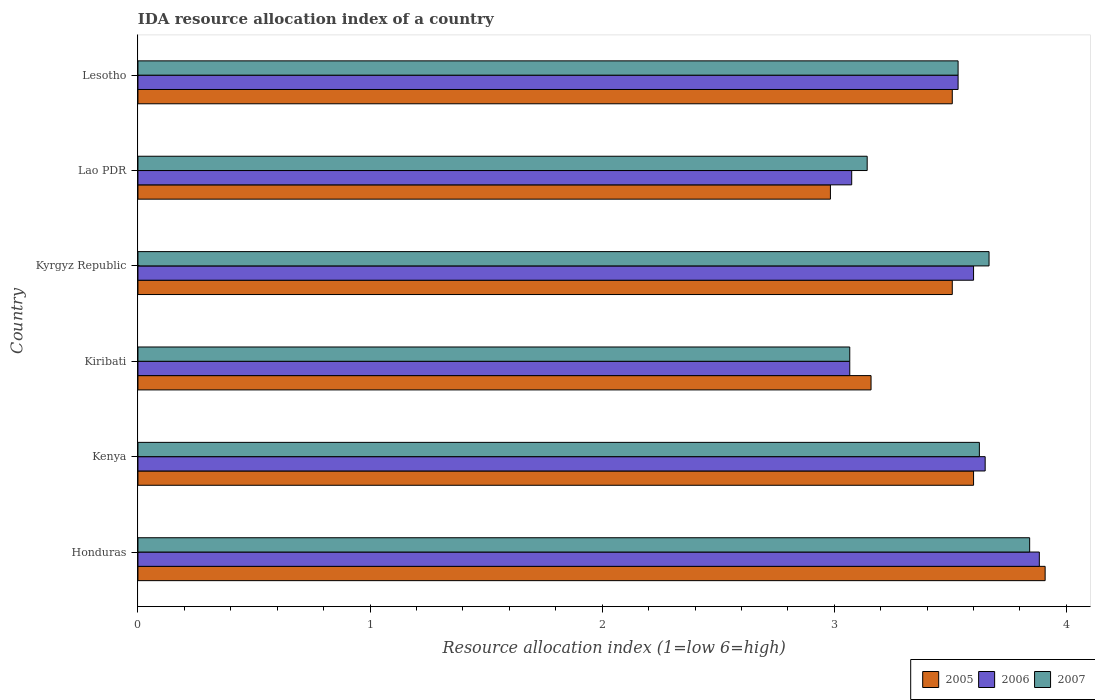How many different coloured bars are there?
Provide a short and direct response. 3. How many groups of bars are there?
Your answer should be compact. 6. What is the label of the 6th group of bars from the top?
Provide a succinct answer. Honduras. In how many cases, is the number of bars for a given country not equal to the number of legend labels?
Provide a short and direct response. 0. What is the IDA resource allocation index in 2007 in Lesotho?
Offer a terse response. 3.53. Across all countries, what is the maximum IDA resource allocation index in 2007?
Your answer should be compact. 3.84. Across all countries, what is the minimum IDA resource allocation index in 2006?
Give a very brief answer. 3.07. In which country was the IDA resource allocation index in 2005 maximum?
Offer a very short reply. Honduras. In which country was the IDA resource allocation index in 2005 minimum?
Make the answer very short. Lao PDR. What is the total IDA resource allocation index in 2007 in the graph?
Offer a very short reply. 20.88. What is the difference between the IDA resource allocation index in 2007 in Honduras and that in Kenya?
Your answer should be compact. 0.22. What is the difference between the IDA resource allocation index in 2005 in Honduras and the IDA resource allocation index in 2006 in Kenya?
Your answer should be compact. 0.26. What is the average IDA resource allocation index in 2006 per country?
Your answer should be very brief. 3.47. What is the difference between the IDA resource allocation index in 2005 and IDA resource allocation index in 2007 in Honduras?
Provide a succinct answer. 0.07. In how many countries, is the IDA resource allocation index in 2005 greater than 0.2 ?
Ensure brevity in your answer.  6. What is the ratio of the IDA resource allocation index in 2007 in Kiribati to that in Lesotho?
Make the answer very short. 0.87. What is the difference between the highest and the second highest IDA resource allocation index in 2006?
Make the answer very short. 0.23. What is the difference between the highest and the lowest IDA resource allocation index in 2005?
Your answer should be very brief. 0.93. In how many countries, is the IDA resource allocation index in 2006 greater than the average IDA resource allocation index in 2006 taken over all countries?
Provide a succinct answer. 4. Is the sum of the IDA resource allocation index in 2006 in Honduras and Lesotho greater than the maximum IDA resource allocation index in 2005 across all countries?
Provide a short and direct response. Yes. Is it the case that in every country, the sum of the IDA resource allocation index in 2005 and IDA resource allocation index in 2007 is greater than the IDA resource allocation index in 2006?
Offer a terse response. Yes. How many bars are there?
Offer a terse response. 18. Are all the bars in the graph horizontal?
Your answer should be compact. Yes. How many countries are there in the graph?
Give a very brief answer. 6. Are the values on the major ticks of X-axis written in scientific E-notation?
Provide a short and direct response. No. Does the graph contain any zero values?
Provide a succinct answer. No. Does the graph contain grids?
Keep it short and to the point. No. How many legend labels are there?
Ensure brevity in your answer.  3. What is the title of the graph?
Offer a very short reply. IDA resource allocation index of a country. What is the label or title of the X-axis?
Your answer should be very brief. Resource allocation index (1=low 6=high). What is the Resource allocation index (1=low 6=high) of 2005 in Honduras?
Offer a terse response. 3.91. What is the Resource allocation index (1=low 6=high) in 2006 in Honduras?
Provide a short and direct response. 3.88. What is the Resource allocation index (1=low 6=high) in 2007 in Honduras?
Give a very brief answer. 3.84. What is the Resource allocation index (1=low 6=high) in 2006 in Kenya?
Keep it short and to the point. 3.65. What is the Resource allocation index (1=low 6=high) in 2007 in Kenya?
Provide a succinct answer. 3.62. What is the Resource allocation index (1=low 6=high) in 2005 in Kiribati?
Ensure brevity in your answer.  3.16. What is the Resource allocation index (1=low 6=high) of 2006 in Kiribati?
Ensure brevity in your answer.  3.07. What is the Resource allocation index (1=low 6=high) of 2007 in Kiribati?
Give a very brief answer. 3.07. What is the Resource allocation index (1=low 6=high) in 2005 in Kyrgyz Republic?
Your answer should be very brief. 3.51. What is the Resource allocation index (1=low 6=high) in 2007 in Kyrgyz Republic?
Make the answer very short. 3.67. What is the Resource allocation index (1=low 6=high) in 2005 in Lao PDR?
Ensure brevity in your answer.  2.98. What is the Resource allocation index (1=low 6=high) of 2006 in Lao PDR?
Your answer should be very brief. 3.08. What is the Resource allocation index (1=low 6=high) of 2007 in Lao PDR?
Provide a succinct answer. 3.14. What is the Resource allocation index (1=low 6=high) of 2005 in Lesotho?
Your answer should be very brief. 3.51. What is the Resource allocation index (1=low 6=high) of 2006 in Lesotho?
Provide a succinct answer. 3.53. What is the Resource allocation index (1=low 6=high) of 2007 in Lesotho?
Your answer should be compact. 3.53. Across all countries, what is the maximum Resource allocation index (1=low 6=high) of 2005?
Provide a short and direct response. 3.91. Across all countries, what is the maximum Resource allocation index (1=low 6=high) of 2006?
Your response must be concise. 3.88. Across all countries, what is the maximum Resource allocation index (1=low 6=high) of 2007?
Give a very brief answer. 3.84. Across all countries, what is the minimum Resource allocation index (1=low 6=high) of 2005?
Offer a very short reply. 2.98. Across all countries, what is the minimum Resource allocation index (1=low 6=high) of 2006?
Provide a short and direct response. 3.07. Across all countries, what is the minimum Resource allocation index (1=low 6=high) of 2007?
Make the answer very short. 3.07. What is the total Resource allocation index (1=low 6=high) of 2005 in the graph?
Give a very brief answer. 20.67. What is the total Resource allocation index (1=low 6=high) in 2006 in the graph?
Your response must be concise. 20.81. What is the total Resource allocation index (1=low 6=high) in 2007 in the graph?
Your response must be concise. 20.88. What is the difference between the Resource allocation index (1=low 6=high) of 2005 in Honduras and that in Kenya?
Provide a succinct answer. 0.31. What is the difference between the Resource allocation index (1=low 6=high) of 2006 in Honduras and that in Kenya?
Your answer should be very brief. 0.23. What is the difference between the Resource allocation index (1=low 6=high) in 2007 in Honduras and that in Kenya?
Your response must be concise. 0.22. What is the difference between the Resource allocation index (1=low 6=high) of 2005 in Honduras and that in Kiribati?
Ensure brevity in your answer.  0.75. What is the difference between the Resource allocation index (1=low 6=high) of 2006 in Honduras and that in Kiribati?
Ensure brevity in your answer.  0.82. What is the difference between the Resource allocation index (1=low 6=high) in 2007 in Honduras and that in Kiribati?
Give a very brief answer. 0.78. What is the difference between the Resource allocation index (1=low 6=high) of 2006 in Honduras and that in Kyrgyz Republic?
Your response must be concise. 0.28. What is the difference between the Resource allocation index (1=low 6=high) of 2007 in Honduras and that in Kyrgyz Republic?
Offer a very short reply. 0.17. What is the difference between the Resource allocation index (1=low 6=high) of 2005 in Honduras and that in Lao PDR?
Offer a terse response. 0.93. What is the difference between the Resource allocation index (1=low 6=high) of 2006 in Honduras and that in Lao PDR?
Ensure brevity in your answer.  0.81. What is the difference between the Resource allocation index (1=low 6=high) of 2007 in Honduras and that in Lao PDR?
Your response must be concise. 0.7. What is the difference between the Resource allocation index (1=low 6=high) in 2007 in Honduras and that in Lesotho?
Make the answer very short. 0.31. What is the difference between the Resource allocation index (1=low 6=high) of 2005 in Kenya and that in Kiribati?
Offer a very short reply. 0.44. What is the difference between the Resource allocation index (1=low 6=high) of 2006 in Kenya and that in Kiribati?
Offer a very short reply. 0.58. What is the difference between the Resource allocation index (1=low 6=high) in 2007 in Kenya and that in Kiribati?
Provide a short and direct response. 0.56. What is the difference between the Resource allocation index (1=low 6=high) in 2005 in Kenya and that in Kyrgyz Republic?
Give a very brief answer. 0.09. What is the difference between the Resource allocation index (1=low 6=high) in 2007 in Kenya and that in Kyrgyz Republic?
Your response must be concise. -0.04. What is the difference between the Resource allocation index (1=low 6=high) of 2005 in Kenya and that in Lao PDR?
Make the answer very short. 0.62. What is the difference between the Resource allocation index (1=low 6=high) of 2006 in Kenya and that in Lao PDR?
Offer a very short reply. 0.57. What is the difference between the Resource allocation index (1=low 6=high) of 2007 in Kenya and that in Lao PDR?
Make the answer very short. 0.48. What is the difference between the Resource allocation index (1=low 6=high) in 2005 in Kenya and that in Lesotho?
Your response must be concise. 0.09. What is the difference between the Resource allocation index (1=low 6=high) of 2006 in Kenya and that in Lesotho?
Offer a terse response. 0.12. What is the difference between the Resource allocation index (1=low 6=high) in 2007 in Kenya and that in Lesotho?
Your answer should be compact. 0.09. What is the difference between the Resource allocation index (1=low 6=high) of 2005 in Kiribati and that in Kyrgyz Republic?
Your answer should be very brief. -0.35. What is the difference between the Resource allocation index (1=low 6=high) of 2006 in Kiribati and that in Kyrgyz Republic?
Keep it short and to the point. -0.53. What is the difference between the Resource allocation index (1=low 6=high) of 2005 in Kiribati and that in Lao PDR?
Your response must be concise. 0.17. What is the difference between the Resource allocation index (1=low 6=high) in 2006 in Kiribati and that in Lao PDR?
Provide a short and direct response. -0.01. What is the difference between the Resource allocation index (1=low 6=high) in 2007 in Kiribati and that in Lao PDR?
Give a very brief answer. -0.07. What is the difference between the Resource allocation index (1=low 6=high) of 2005 in Kiribati and that in Lesotho?
Offer a terse response. -0.35. What is the difference between the Resource allocation index (1=low 6=high) in 2006 in Kiribati and that in Lesotho?
Offer a very short reply. -0.47. What is the difference between the Resource allocation index (1=low 6=high) of 2007 in Kiribati and that in Lesotho?
Ensure brevity in your answer.  -0.47. What is the difference between the Resource allocation index (1=low 6=high) in 2005 in Kyrgyz Republic and that in Lao PDR?
Provide a short and direct response. 0.53. What is the difference between the Resource allocation index (1=low 6=high) in 2006 in Kyrgyz Republic and that in Lao PDR?
Offer a terse response. 0.53. What is the difference between the Resource allocation index (1=low 6=high) of 2007 in Kyrgyz Republic and that in Lao PDR?
Keep it short and to the point. 0.53. What is the difference between the Resource allocation index (1=low 6=high) in 2005 in Kyrgyz Republic and that in Lesotho?
Offer a very short reply. 0. What is the difference between the Resource allocation index (1=low 6=high) of 2006 in Kyrgyz Republic and that in Lesotho?
Provide a succinct answer. 0.07. What is the difference between the Resource allocation index (1=low 6=high) of 2007 in Kyrgyz Republic and that in Lesotho?
Offer a terse response. 0.13. What is the difference between the Resource allocation index (1=low 6=high) in 2005 in Lao PDR and that in Lesotho?
Give a very brief answer. -0.53. What is the difference between the Resource allocation index (1=low 6=high) of 2006 in Lao PDR and that in Lesotho?
Keep it short and to the point. -0.46. What is the difference between the Resource allocation index (1=low 6=high) of 2007 in Lao PDR and that in Lesotho?
Ensure brevity in your answer.  -0.39. What is the difference between the Resource allocation index (1=low 6=high) in 2005 in Honduras and the Resource allocation index (1=low 6=high) in 2006 in Kenya?
Offer a terse response. 0.26. What is the difference between the Resource allocation index (1=low 6=high) of 2005 in Honduras and the Resource allocation index (1=low 6=high) of 2007 in Kenya?
Give a very brief answer. 0.28. What is the difference between the Resource allocation index (1=low 6=high) of 2006 in Honduras and the Resource allocation index (1=low 6=high) of 2007 in Kenya?
Keep it short and to the point. 0.26. What is the difference between the Resource allocation index (1=low 6=high) in 2005 in Honduras and the Resource allocation index (1=low 6=high) in 2006 in Kiribati?
Give a very brief answer. 0.84. What is the difference between the Resource allocation index (1=low 6=high) in 2005 in Honduras and the Resource allocation index (1=low 6=high) in 2007 in Kiribati?
Provide a succinct answer. 0.84. What is the difference between the Resource allocation index (1=low 6=high) in 2006 in Honduras and the Resource allocation index (1=low 6=high) in 2007 in Kiribati?
Your answer should be very brief. 0.82. What is the difference between the Resource allocation index (1=low 6=high) of 2005 in Honduras and the Resource allocation index (1=low 6=high) of 2006 in Kyrgyz Republic?
Offer a terse response. 0.31. What is the difference between the Resource allocation index (1=low 6=high) in 2005 in Honduras and the Resource allocation index (1=low 6=high) in 2007 in Kyrgyz Republic?
Provide a succinct answer. 0.24. What is the difference between the Resource allocation index (1=low 6=high) in 2006 in Honduras and the Resource allocation index (1=low 6=high) in 2007 in Kyrgyz Republic?
Offer a terse response. 0.22. What is the difference between the Resource allocation index (1=low 6=high) of 2005 in Honduras and the Resource allocation index (1=low 6=high) of 2006 in Lao PDR?
Offer a terse response. 0.83. What is the difference between the Resource allocation index (1=low 6=high) of 2005 in Honduras and the Resource allocation index (1=low 6=high) of 2007 in Lao PDR?
Make the answer very short. 0.77. What is the difference between the Resource allocation index (1=low 6=high) in 2006 in Honduras and the Resource allocation index (1=low 6=high) in 2007 in Lao PDR?
Your answer should be compact. 0.74. What is the difference between the Resource allocation index (1=low 6=high) in 2005 in Honduras and the Resource allocation index (1=low 6=high) in 2007 in Lesotho?
Your answer should be compact. 0.38. What is the difference between the Resource allocation index (1=low 6=high) in 2005 in Kenya and the Resource allocation index (1=low 6=high) in 2006 in Kiribati?
Provide a short and direct response. 0.53. What is the difference between the Resource allocation index (1=low 6=high) in 2005 in Kenya and the Resource allocation index (1=low 6=high) in 2007 in Kiribati?
Give a very brief answer. 0.53. What is the difference between the Resource allocation index (1=low 6=high) of 2006 in Kenya and the Resource allocation index (1=low 6=high) of 2007 in Kiribati?
Ensure brevity in your answer.  0.58. What is the difference between the Resource allocation index (1=low 6=high) in 2005 in Kenya and the Resource allocation index (1=low 6=high) in 2006 in Kyrgyz Republic?
Give a very brief answer. 0. What is the difference between the Resource allocation index (1=low 6=high) in 2005 in Kenya and the Resource allocation index (1=low 6=high) in 2007 in Kyrgyz Republic?
Offer a terse response. -0.07. What is the difference between the Resource allocation index (1=low 6=high) of 2006 in Kenya and the Resource allocation index (1=low 6=high) of 2007 in Kyrgyz Republic?
Offer a terse response. -0.02. What is the difference between the Resource allocation index (1=low 6=high) in 2005 in Kenya and the Resource allocation index (1=low 6=high) in 2006 in Lao PDR?
Your response must be concise. 0.53. What is the difference between the Resource allocation index (1=low 6=high) of 2005 in Kenya and the Resource allocation index (1=low 6=high) of 2007 in Lao PDR?
Offer a very short reply. 0.46. What is the difference between the Resource allocation index (1=low 6=high) of 2006 in Kenya and the Resource allocation index (1=low 6=high) of 2007 in Lao PDR?
Your answer should be compact. 0.51. What is the difference between the Resource allocation index (1=low 6=high) in 2005 in Kenya and the Resource allocation index (1=low 6=high) in 2006 in Lesotho?
Your answer should be very brief. 0.07. What is the difference between the Resource allocation index (1=low 6=high) of 2005 in Kenya and the Resource allocation index (1=low 6=high) of 2007 in Lesotho?
Ensure brevity in your answer.  0.07. What is the difference between the Resource allocation index (1=low 6=high) of 2006 in Kenya and the Resource allocation index (1=low 6=high) of 2007 in Lesotho?
Make the answer very short. 0.12. What is the difference between the Resource allocation index (1=low 6=high) in 2005 in Kiribati and the Resource allocation index (1=low 6=high) in 2006 in Kyrgyz Republic?
Provide a short and direct response. -0.44. What is the difference between the Resource allocation index (1=low 6=high) of 2005 in Kiribati and the Resource allocation index (1=low 6=high) of 2007 in Kyrgyz Republic?
Provide a succinct answer. -0.51. What is the difference between the Resource allocation index (1=low 6=high) of 2006 in Kiribati and the Resource allocation index (1=low 6=high) of 2007 in Kyrgyz Republic?
Provide a short and direct response. -0.6. What is the difference between the Resource allocation index (1=low 6=high) in 2005 in Kiribati and the Resource allocation index (1=low 6=high) in 2006 in Lao PDR?
Your response must be concise. 0.08. What is the difference between the Resource allocation index (1=low 6=high) in 2005 in Kiribati and the Resource allocation index (1=low 6=high) in 2007 in Lao PDR?
Your response must be concise. 0.02. What is the difference between the Resource allocation index (1=low 6=high) in 2006 in Kiribati and the Resource allocation index (1=low 6=high) in 2007 in Lao PDR?
Ensure brevity in your answer.  -0.07. What is the difference between the Resource allocation index (1=low 6=high) in 2005 in Kiribati and the Resource allocation index (1=low 6=high) in 2006 in Lesotho?
Give a very brief answer. -0.38. What is the difference between the Resource allocation index (1=low 6=high) in 2005 in Kiribati and the Resource allocation index (1=low 6=high) in 2007 in Lesotho?
Your answer should be compact. -0.38. What is the difference between the Resource allocation index (1=low 6=high) of 2006 in Kiribati and the Resource allocation index (1=low 6=high) of 2007 in Lesotho?
Make the answer very short. -0.47. What is the difference between the Resource allocation index (1=low 6=high) in 2005 in Kyrgyz Republic and the Resource allocation index (1=low 6=high) in 2006 in Lao PDR?
Make the answer very short. 0.43. What is the difference between the Resource allocation index (1=low 6=high) in 2005 in Kyrgyz Republic and the Resource allocation index (1=low 6=high) in 2007 in Lao PDR?
Give a very brief answer. 0.37. What is the difference between the Resource allocation index (1=low 6=high) of 2006 in Kyrgyz Republic and the Resource allocation index (1=low 6=high) of 2007 in Lao PDR?
Offer a very short reply. 0.46. What is the difference between the Resource allocation index (1=low 6=high) in 2005 in Kyrgyz Republic and the Resource allocation index (1=low 6=high) in 2006 in Lesotho?
Make the answer very short. -0.03. What is the difference between the Resource allocation index (1=low 6=high) of 2005 in Kyrgyz Republic and the Resource allocation index (1=low 6=high) of 2007 in Lesotho?
Give a very brief answer. -0.03. What is the difference between the Resource allocation index (1=low 6=high) of 2006 in Kyrgyz Republic and the Resource allocation index (1=low 6=high) of 2007 in Lesotho?
Make the answer very short. 0.07. What is the difference between the Resource allocation index (1=low 6=high) in 2005 in Lao PDR and the Resource allocation index (1=low 6=high) in 2006 in Lesotho?
Give a very brief answer. -0.55. What is the difference between the Resource allocation index (1=low 6=high) of 2005 in Lao PDR and the Resource allocation index (1=low 6=high) of 2007 in Lesotho?
Give a very brief answer. -0.55. What is the difference between the Resource allocation index (1=low 6=high) in 2006 in Lao PDR and the Resource allocation index (1=low 6=high) in 2007 in Lesotho?
Ensure brevity in your answer.  -0.46. What is the average Resource allocation index (1=low 6=high) of 2005 per country?
Offer a terse response. 3.44. What is the average Resource allocation index (1=low 6=high) in 2006 per country?
Your response must be concise. 3.47. What is the average Resource allocation index (1=low 6=high) of 2007 per country?
Provide a succinct answer. 3.48. What is the difference between the Resource allocation index (1=low 6=high) in 2005 and Resource allocation index (1=low 6=high) in 2006 in Honduras?
Offer a terse response. 0.03. What is the difference between the Resource allocation index (1=low 6=high) in 2005 and Resource allocation index (1=low 6=high) in 2007 in Honduras?
Provide a short and direct response. 0.07. What is the difference between the Resource allocation index (1=low 6=high) in 2006 and Resource allocation index (1=low 6=high) in 2007 in Honduras?
Provide a short and direct response. 0.04. What is the difference between the Resource allocation index (1=low 6=high) of 2005 and Resource allocation index (1=low 6=high) of 2006 in Kenya?
Your response must be concise. -0.05. What is the difference between the Resource allocation index (1=low 6=high) of 2005 and Resource allocation index (1=low 6=high) of 2007 in Kenya?
Provide a short and direct response. -0.03. What is the difference between the Resource allocation index (1=low 6=high) of 2006 and Resource allocation index (1=low 6=high) of 2007 in Kenya?
Your answer should be very brief. 0.03. What is the difference between the Resource allocation index (1=low 6=high) in 2005 and Resource allocation index (1=low 6=high) in 2006 in Kiribati?
Your answer should be compact. 0.09. What is the difference between the Resource allocation index (1=low 6=high) of 2005 and Resource allocation index (1=low 6=high) of 2007 in Kiribati?
Keep it short and to the point. 0.09. What is the difference between the Resource allocation index (1=low 6=high) of 2005 and Resource allocation index (1=low 6=high) of 2006 in Kyrgyz Republic?
Provide a succinct answer. -0.09. What is the difference between the Resource allocation index (1=low 6=high) in 2005 and Resource allocation index (1=low 6=high) in 2007 in Kyrgyz Republic?
Ensure brevity in your answer.  -0.16. What is the difference between the Resource allocation index (1=low 6=high) of 2006 and Resource allocation index (1=low 6=high) of 2007 in Kyrgyz Republic?
Keep it short and to the point. -0.07. What is the difference between the Resource allocation index (1=low 6=high) in 2005 and Resource allocation index (1=low 6=high) in 2006 in Lao PDR?
Provide a succinct answer. -0.09. What is the difference between the Resource allocation index (1=low 6=high) of 2005 and Resource allocation index (1=low 6=high) of 2007 in Lao PDR?
Give a very brief answer. -0.16. What is the difference between the Resource allocation index (1=low 6=high) of 2006 and Resource allocation index (1=low 6=high) of 2007 in Lao PDR?
Ensure brevity in your answer.  -0.07. What is the difference between the Resource allocation index (1=low 6=high) in 2005 and Resource allocation index (1=low 6=high) in 2006 in Lesotho?
Keep it short and to the point. -0.03. What is the difference between the Resource allocation index (1=low 6=high) of 2005 and Resource allocation index (1=low 6=high) of 2007 in Lesotho?
Provide a short and direct response. -0.03. What is the ratio of the Resource allocation index (1=low 6=high) of 2005 in Honduras to that in Kenya?
Give a very brief answer. 1.09. What is the ratio of the Resource allocation index (1=low 6=high) in 2006 in Honduras to that in Kenya?
Make the answer very short. 1.06. What is the ratio of the Resource allocation index (1=low 6=high) in 2007 in Honduras to that in Kenya?
Offer a terse response. 1.06. What is the ratio of the Resource allocation index (1=low 6=high) of 2005 in Honduras to that in Kiribati?
Give a very brief answer. 1.24. What is the ratio of the Resource allocation index (1=low 6=high) of 2006 in Honduras to that in Kiribati?
Make the answer very short. 1.27. What is the ratio of the Resource allocation index (1=low 6=high) of 2007 in Honduras to that in Kiribati?
Your answer should be very brief. 1.25. What is the ratio of the Resource allocation index (1=low 6=high) of 2005 in Honduras to that in Kyrgyz Republic?
Your answer should be very brief. 1.11. What is the ratio of the Resource allocation index (1=low 6=high) in 2006 in Honduras to that in Kyrgyz Republic?
Offer a very short reply. 1.08. What is the ratio of the Resource allocation index (1=low 6=high) of 2007 in Honduras to that in Kyrgyz Republic?
Offer a terse response. 1.05. What is the ratio of the Resource allocation index (1=low 6=high) of 2005 in Honduras to that in Lao PDR?
Give a very brief answer. 1.31. What is the ratio of the Resource allocation index (1=low 6=high) of 2006 in Honduras to that in Lao PDR?
Your answer should be compact. 1.26. What is the ratio of the Resource allocation index (1=low 6=high) of 2007 in Honduras to that in Lao PDR?
Provide a succinct answer. 1.22. What is the ratio of the Resource allocation index (1=low 6=high) of 2005 in Honduras to that in Lesotho?
Your answer should be compact. 1.11. What is the ratio of the Resource allocation index (1=low 6=high) of 2006 in Honduras to that in Lesotho?
Offer a very short reply. 1.1. What is the ratio of the Resource allocation index (1=low 6=high) in 2007 in Honduras to that in Lesotho?
Your response must be concise. 1.09. What is the ratio of the Resource allocation index (1=low 6=high) of 2005 in Kenya to that in Kiribati?
Provide a short and direct response. 1.14. What is the ratio of the Resource allocation index (1=low 6=high) in 2006 in Kenya to that in Kiribati?
Your answer should be compact. 1.19. What is the ratio of the Resource allocation index (1=low 6=high) of 2007 in Kenya to that in Kiribati?
Make the answer very short. 1.18. What is the ratio of the Resource allocation index (1=low 6=high) in 2005 in Kenya to that in Kyrgyz Republic?
Provide a short and direct response. 1.03. What is the ratio of the Resource allocation index (1=low 6=high) of 2006 in Kenya to that in Kyrgyz Republic?
Give a very brief answer. 1.01. What is the ratio of the Resource allocation index (1=low 6=high) in 2007 in Kenya to that in Kyrgyz Republic?
Ensure brevity in your answer.  0.99. What is the ratio of the Resource allocation index (1=low 6=high) in 2005 in Kenya to that in Lao PDR?
Make the answer very short. 1.21. What is the ratio of the Resource allocation index (1=low 6=high) in 2006 in Kenya to that in Lao PDR?
Make the answer very short. 1.19. What is the ratio of the Resource allocation index (1=low 6=high) of 2007 in Kenya to that in Lao PDR?
Provide a short and direct response. 1.15. What is the ratio of the Resource allocation index (1=low 6=high) in 2005 in Kenya to that in Lesotho?
Ensure brevity in your answer.  1.03. What is the ratio of the Resource allocation index (1=low 6=high) in 2006 in Kenya to that in Lesotho?
Provide a short and direct response. 1.03. What is the ratio of the Resource allocation index (1=low 6=high) in 2007 in Kenya to that in Lesotho?
Your answer should be very brief. 1.03. What is the ratio of the Resource allocation index (1=low 6=high) of 2005 in Kiribati to that in Kyrgyz Republic?
Offer a terse response. 0.9. What is the ratio of the Resource allocation index (1=low 6=high) in 2006 in Kiribati to that in Kyrgyz Republic?
Keep it short and to the point. 0.85. What is the ratio of the Resource allocation index (1=low 6=high) of 2007 in Kiribati to that in Kyrgyz Republic?
Keep it short and to the point. 0.84. What is the ratio of the Resource allocation index (1=low 6=high) of 2005 in Kiribati to that in Lao PDR?
Offer a very short reply. 1.06. What is the ratio of the Resource allocation index (1=low 6=high) in 2006 in Kiribati to that in Lao PDR?
Offer a very short reply. 1. What is the ratio of the Resource allocation index (1=low 6=high) in 2007 in Kiribati to that in Lao PDR?
Ensure brevity in your answer.  0.98. What is the ratio of the Resource allocation index (1=low 6=high) of 2005 in Kiribati to that in Lesotho?
Your response must be concise. 0.9. What is the ratio of the Resource allocation index (1=low 6=high) in 2006 in Kiribati to that in Lesotho?
Your answer should be compact. 0.87. What is the ratio of the Resource allocation index (1=low 6=high) of 2007 in Kiribati to that in Lesotho?
Provide a short and direct response. 0.87. What is the ratio of the Resource allocation index (1=low 6=high) of 2005 in Kyrgyz Republic to that in Lao PDR?
Offer a terse response. 1.18. What is the ratio of the Resource allocation index (1=low 6=high) of 2006 in Kyrgyz Republic to that in Lao PDR?
Offer a terse response. 1.17. What is the ratio of the Resource allocation index (1=low 6=high) of 2007 in Kyrgyz Republic to that in Lao PDR?
Provide a succinct answer. 1.17. What is the ratio of the Resource allocation index (1=low 6=high) of 2005 in Kyrgyz Republic to that in Lesotho?
Your answer should be very brief. 1. What is the ratio of the Resource allocation index (1=low 6=high) in 2006 in Kyrgyz Republic to that in Lesotho?
Provide a succinct answer. 1.02. What is the ratio of the Resource allocation index (1=low 6=high) in 2007 in Kyrgyz Republic to that in Lesotho?
Your answer should be compact. 1.04. What is the ratio of the Resource allocation index (1=low 6=high) of 2005 in Lao PDR to that in Lesotho?
Keep it short and to the point. 0.85. What is the ratio of the Resource allocation index (1=low 6=high) of 2006 in Lao PDR to that in Lesotho?
Your answer should be compact. 0.87. What is the ratio of the Resource allocation index (1=low 6=high) in 2007 in Lao PDR to that in Lesotho?
Ensure brevity in your answer.  0.89. What is the difference between the highest and the second highest Resource allocation index (1=low 6=high) in 2005?
Provide a short and direct response. 0.31. What is the difference between the highest and the second highest Resource allocation index (1=low 6=high) in 2006?
Ensure brevity in your answer.  0.23. What is the difference between the highest and the second highest Resource allocation index (1=low 6=high) in 2007?
Provide a short and direct response. 0.17. What is the difference between the highest and the lowest Resource allocation index (1=low 6=high) of 2005?
Ensure brevity in your answer.  0.93. What is the difference between the highest and the lowest Resource allocation index (1=low 6=high) of 2006?
Keep it short and to the point. 0.82. What is the difference between the highest and the lowest Resource allocation index (1=low 6=high) in 2007?
Keep it short and to the point. 0.78. 